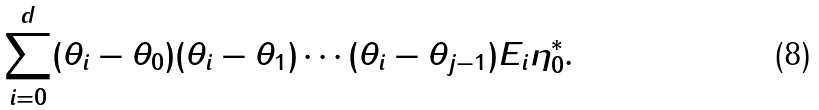Convert formula to latex. <formula><loc_0><loc_0><loc_500><loc_500>\sum _ { i = 0 } ^ { d } ( \theta _ { i } - \theta _ { 0 } ) ( \theta _ { i } - \theta _ { 1 } ) \cdots ( \theta _ { i } - \theta _ { j - 1 } ) E _ { i } \eta ^ { * } _ { 0 } .</formula> 